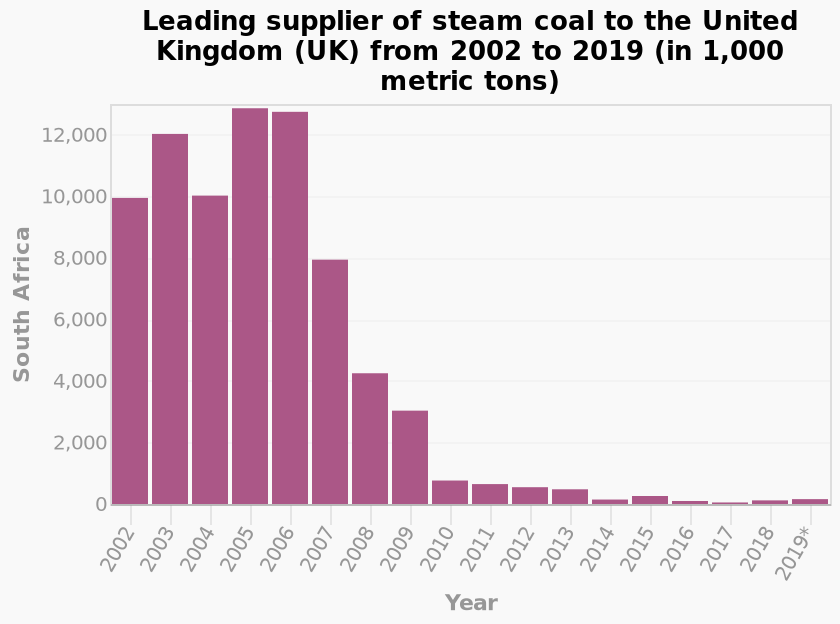<image>
What is the title of the bar plot?  The title of the bar plot is "Leading supplier of steam coal to the United Kingdom (UK) from 2002 to 2019 (in 1,000 metric tons)." What is the range of years covered in the bar plot? The bar plot covers the years from 2002 to 2019. Which country had the second highest combined mobile traffic in 2016?  The UK. Which year had the lowest net income?  2017. Offer a thorough analysis of the image. The years of 2005 and 2006 saw South Africa's largest export of steam coal to the UK. 2017 was the lowest yearly export of steam coal from South Africa to the UK. What does the y-axis plot in the bar plot?  The y-axis plots South Africa. Is the title of the bar plot "Leading supplier of steam coal to the United Kingdom (UK) from 2002 to 2018 (in 1,000 metric tons)"? No. The title of the bar plot is "Leading supplier of steam coal to the United Kingdom (UK) from 2002 to 2019 (in 1,000 metric tons)." 